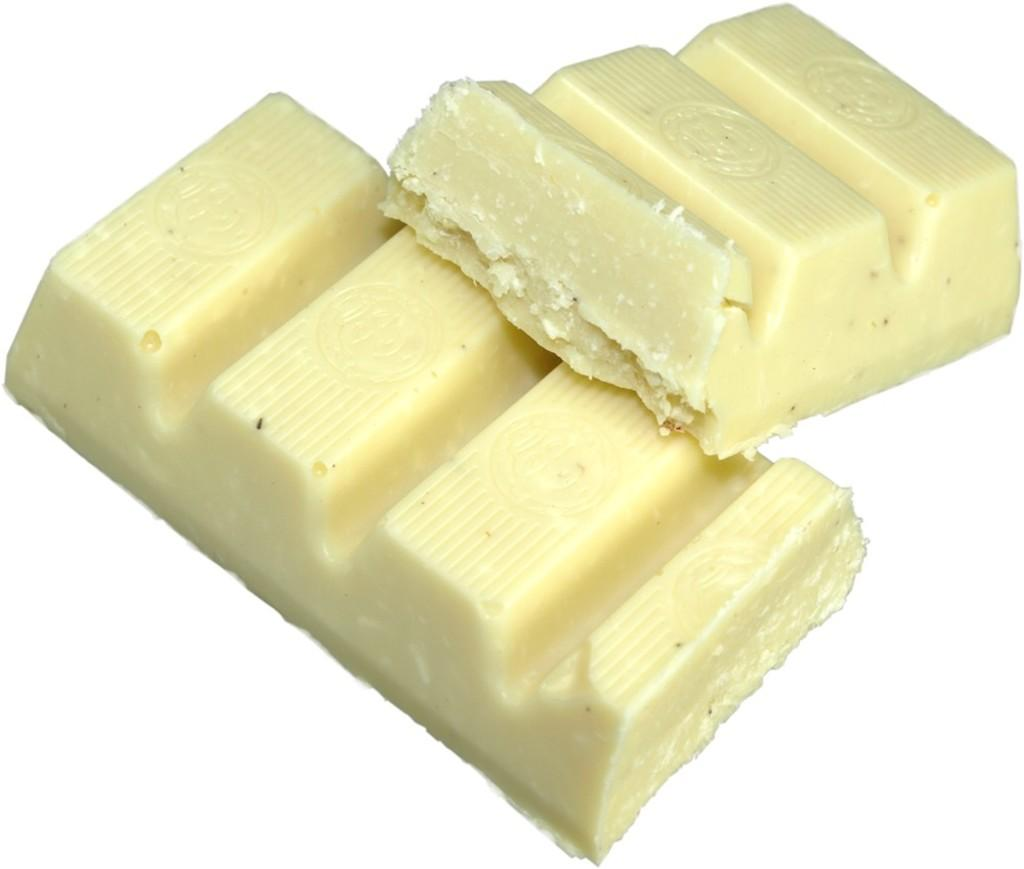What type of chocolate is present in the image? There are two bars of white chocolate in the image. What color are the bars of chocolate? The bars of chocolate are white. What is the surface on which the chocolate is placed? The bars of white chocolate are on a white surface. What songs are being sung by the chocolate in the image? There are no songs being sung by the chocolate in the image, as chocolate is an inanimate object and cannot sing. 